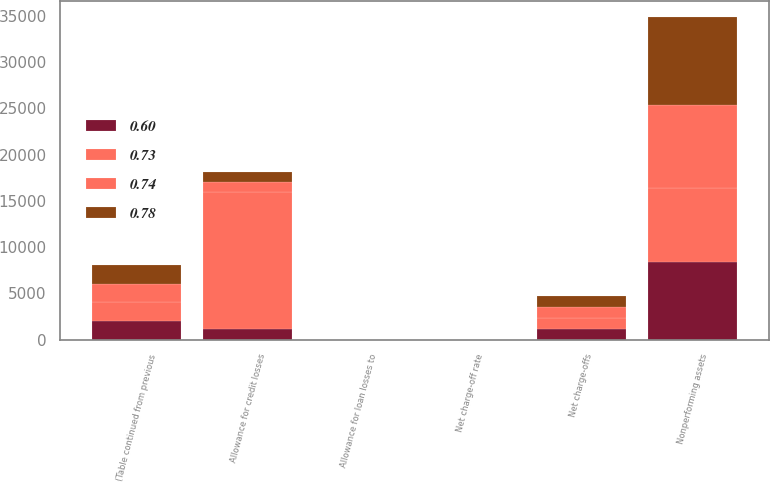Convert chart. <chart><loc_0><loc_0><loc_500><loc_500><stacked_bar_chart><ecel><fcel>(Table continued from previous<fcel>Allowance for credit losses<fcel>Allowance for loan losses to<fcel>Nonperforming assets<fcel>Net charge-offs<fcel>Net charge-off rate<nl><fcel>0.73<fcel>2014<fcel>14807<fcel>1.55<fcel>7967<fcel>1218<fcel>0.65<nl><fcel>0.6<fcel>2014<fcel>1114<fcel>1.63<fcel>8390<fcel>1114<fcel>0.6<nl><fcel>0.74<fcel>2014<fcel>1114<fcel>1.69<fcel>9017<fcel>1158<fcel>0.64<nl><fcel>0.78<fcel>2014<fcel>1114<fcel>1.75<fcel>9473<fcel>1269<fcel>0.71<nl></chart> 